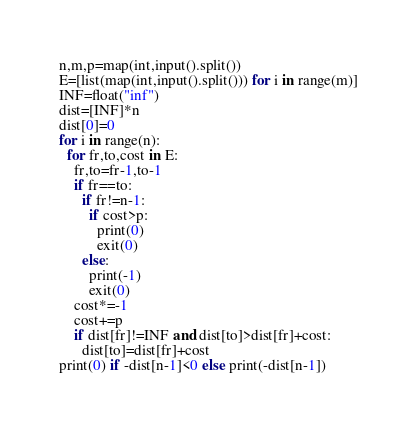Convert code to text. <code><loc_0><loc_0><loc_500><loc_500><_Python_>n,m,p=map(int,input().split())
E=[list(map(int,input().split())) for i in range(m)]
INF=float("inf")
dist=[INF]*n
dist[0]=0
for i in range(n):
  for fr,to,cost in E:
    fr,to=fr-1,to-1
    if fr==to:
      if fr!=n-1:
        if cost>p:
          print(0)
          exit(0)
      else:
        print(-1)
        exit(0)
    cost*=-1
    cost+=p
    if dist[fr]!=INF and dist[to]>dist[fr]+cost:
      dist[to]=dist[fr]+cost
print(0) if -dist[n-1]<0 else print(-dist[n-1])</code> 